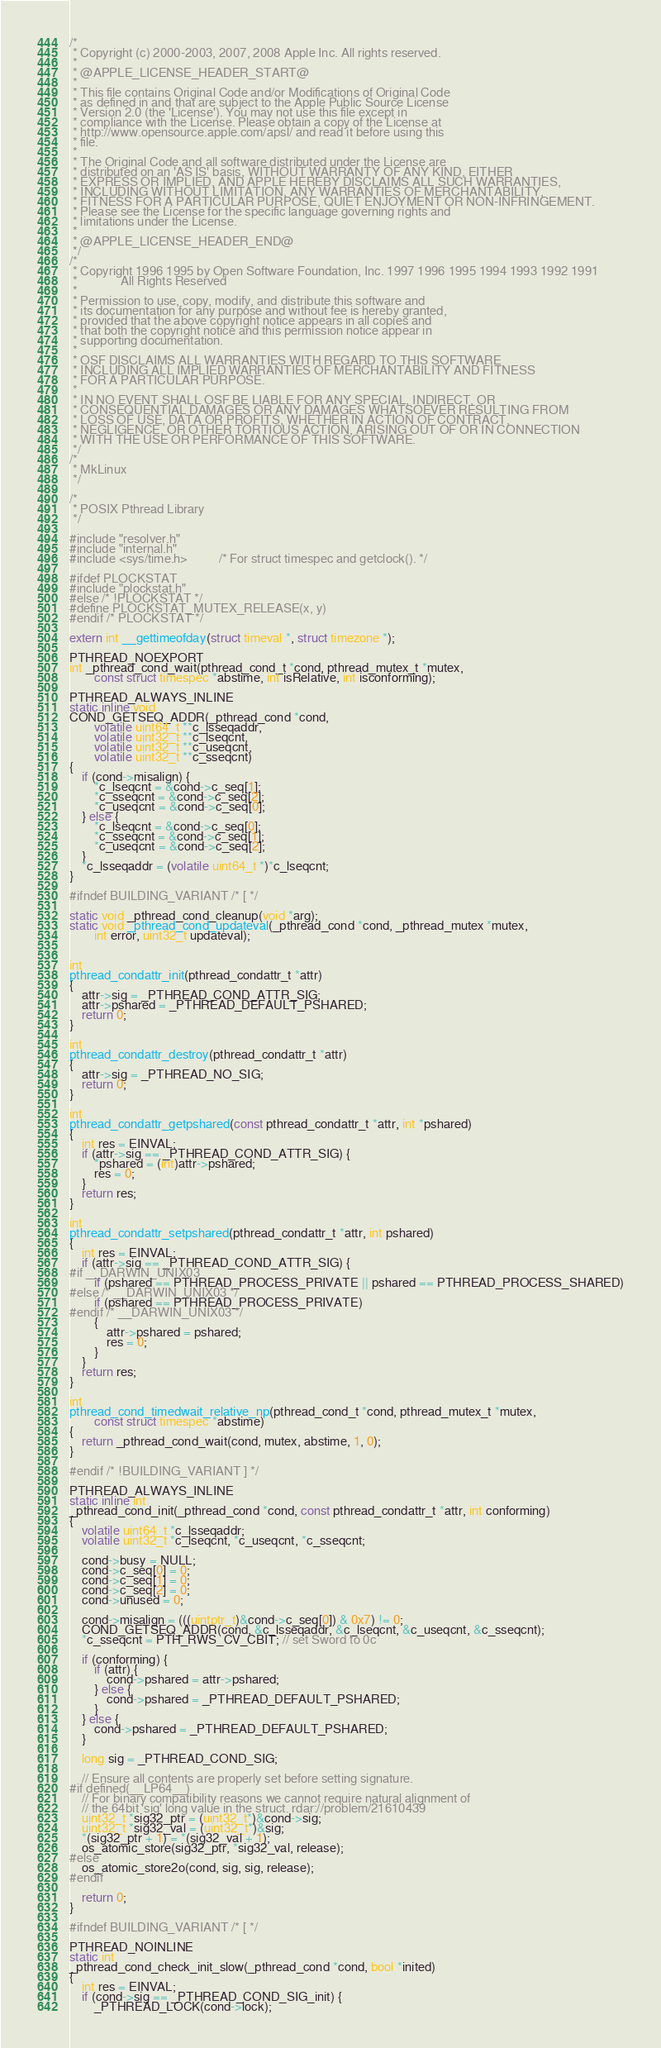Convert code to text. <code><loc_0><loc_0><loc_500><loc_500><_C_>/*
 * Copyright (c) 2000-2003, 2007, 2008 Apple Inc. All rights reserved.
 *
 * @APPLE_LICENSE_HEADER_START@
 *
 * This file contains Original Code and/or Modifications of Original Code
 * as defined in and that are subject to the Apple Public Source License
 * Version 2.0 (the 'License'). You may not use this file except in
 * compliance with the License. Please obtain a copy of the License at
 * http://www.opensource.apple.com/apsl/ and read it before using this
 * file.
 *
 * The Original Code and all software distributed under the License are
 * distributed on an 'AS IS' basis, WITHOUT WARRANTY OF ANY KIND, EITHER
 * EXPRESS OR IMPLIED, AND APPLE HEREBY DISCLAIMS ALL SUCH WARRANTIES,
 * INCLUDING WITHOUT LIMITATION, ANY WARRANTIES OF MERCHANTABILITY,
 * FITNESS FOR A PARTICULAR PURPOSE, QUIET ENJOYMENT OR NON-INFRINGEMENT.
 * Please see the License for the specific language governing rights and
 * limitations under the License.
 *
 * @APPLE_LICENSE_HEADER_END@
 */
/*
 * Copyright 1996 1995 by Open Software Foundation, Inc. 1997 1996 1995 1994 1993 1992 1991
 *              All Rights Reserved
 *
 * Permission to use, copy, modify, and distribute this software and
 * its documentation for any purpose and without fee is hereby granted,
 * provided that the above copyright notice appears in all copies and
 * that both the copyright notice and this permission notice appear in
 * supporting documentation.
 *
 * OSF DISCLAIMS ALL WARRANTIES WITH REGARD TO THIS SOFTWARE
 * INCLUDING ALL IMPLIED WARRANTIES OF MERCHANTABILITY AND FITNESS
 * FOR A PARTICULAR PURPOSE.
 *
 * IN NO EVENT SHALL OSF BE LIABLE FOR ANY SPECIAL, INDIRECT, OR
 * CONSEQUENTIAL DAMAGES OR ANY DAMAGES WHATSOEVER RESULTING FROM
 * LOSS OF USE, DATA OR PROFITS, WHETHER IN ACTION OF CONTRACT,
 * NEGLIGENCE, OR OTHER TORTIOUS ACTION, ARISING OUT OF OR IN CONNECTION
 * WITH THE USE OR PERFORMANCE OF THIS SOFTWARE.
 */
/*
 * MkLinux
 */

/*
 * POSIX Pthread Library
 */

#include "resolver.h"
#include "internal.h"
#include <sys/time.h>	      /* For struct timespec and getclock(). */

#ifdef PLOCKSTAT
#include "plockstat.h"
#else /* !PLOCKSTAT */
#define PLOCKSTAT_MUTEX_RELEASE(x, y)
#endif /* PLOCKSTAT */

extern int __gettimeofday(struct timeval *, struct timezone *);

PTHREAD_NOEXPORT
int _pthread_cond_wait(pthread_cond_t *cond, pthread_mutex_t *mutex,
		const struct timespec *abstime, int isRelative, int isconforming);

PTHREAD_ALWAYS_INLINE
static inline void
COND_GETSEQ_ADDR(_pthread_cond *cond,
		volatile uint64_t **c_lsseqaddr,
		volatile uint32_t **c_lseqcnt,
		volatile uint32_t **c_useqcnt,
		volatile uint32_t **c_sseqcnt)
{
	if (cond->misalign) {
		*c_lseqcnt = &cond->c_seq[1];
		*c_sseqcnt = &cond->c_seq[2];
		*c_useqcnt = &cond->c_seq[0];
	} else {
		*c_lseqcnt = &cond->c_seq[0];
		*c_sseqcnt = &cond->c_seq[1];
		*c_useqcnt = &cond->c_seq[2];
	}
	*c_lsseqaddr = (volatile uint64_t *)*c_lseqcnt;
}

#ifndef BUILDING_VARIANT /* [ */

static void _pthread_cond_cleanup(void *arg);
static void _pthread_cond_updateval(_pthread_cond *cond, _pthread_mutex *mutex,
		int error, uint32_t updateval);


int
pthread_condattr_init(pthread_condattr_t *attr)
{
	attr->sig = _PTHREAD_COND_ATTR_SIG;
	attr->pshared = _PTHREAD_DEFAULT_PSHARED;
	return 0;
}

int
pthread_condattr_destroy(pthread_condattr_t *attr)
{
	attr->sig = _PTHREAD_NO_SIG;
	return 0;
}

int
pthread_condattr_getpshared(const pthread_condattr_t *attr, int *pshared)
{
	int res = EINVAL;
	if (attr->sig == _PTHREAD_COND_ATTR_SIG) {
		*pshared = (int)attr->pshared;
		res = 0;
	}
	return res;
}

int
pthread_condattr_setpshared(pthread_condattr_t *attr, int pshared)
{
	int res = EINVAL;
	if (attr->sig == _PTHREAD_COND_ATTR_SIG) {
#if __DARWIN_UNIX03
		if (pshared == PTHREAD_PROCESS_PRIVATE || pshared == PTHREAD_PROCESS_SHARED)
#else /* __DARWIN_UNIX03 */
		if (pshared == PTHREAD_PROCESS_PRIVATE)
#endif /* __DARWIN_UNIX03 */
		{
			attr->pshared = pshared;
			res = 0;
		}
	}
	return res;
}

int
pthread_cond_timedwait_relative_np(pthread_cond_t *cond, pthread_mutex_t *mutex,
		const struct timespec *abstime)
{
	return _pthread_cond_wait(cond, mutex, abstime, 1, 0);
}

#endif /* !BUILDING_VARIANT ] */

PTHREAD_ALWAYS_INLINE
static inline int
_pthread_cond_init(_pthread_cond *cond, const pthread_condattr_t *attr, int conforming)
{
	volatile uint64_t *c_lsseqaddr;
	volatile uint32_t *c_lseqcnt, *c_useqcnt, *c_sseqcnt;

	cond->busy = NULL;
	cond->c_seq[0] = 0;
	cond->c_seq[1] = 0;
	cond->c_seq[2] = 0;
	cond->unused = 0;

	cond->misalign = (((uintptr_t)&cond->c_seq[0]) & 0x7) != 0;
	COND_GETSEQ_ADDR(cond, &c_lsseqaddr, &c_lseqcnt, &c_useqcnt, &c_sseqcnt);
	*c_sseqcnt = PTH_RWS_CV_CBIT; // set Sword to 0c

	if (conforming) {
		if (attr) {
			cond->pshared = attr->pshared;
		} else {
			cond->pshared = _PTHREAD_DEFAULT_PSHARED;
		}
	} else {
		cond->pshared = _PTHREAD_DEFAULT_PSHARED;
	}

	long sig = _PTHREAD_COND_SIG;

	// Ensure all contents are properly set before setting signature.
#if defined(__LP64__)
	// For binary compatibility reasons we cannot require natural alignment of
	// the 64bit 'sig' long value in the struct. rdar://problem/21610439
	uint32_t *sig32_ptr = (uint32_t*)&cond->sig;
	uint32_t *sig32_val = (uint32_t*)&sig;
	*(sig32_ptr + 1) = *(sig32_val + 1);
	os_atomic_store(sig32_ptr, *sig32_val, release);
#else
	os_atomic_store2o(cond, sig, sig, release);
#endif

	return 0;
}

#ifndef BUILDING_VARIANT /* [ */

PTHREAD_NOINLINE
static int
_pthread_cond_check_init_slow(_pthread_cond *cond, bool *inited)
{
	int res = EINVAL;
	if (cond->sig == _PTHREAD_COND_SIG_init) {
		_PTHREAD_LOCK(cond->lock);</code> 